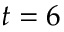Convert formula to latex. <formula><loc_0><loc_0><loc_500><loc_500>t = 6</formula> 